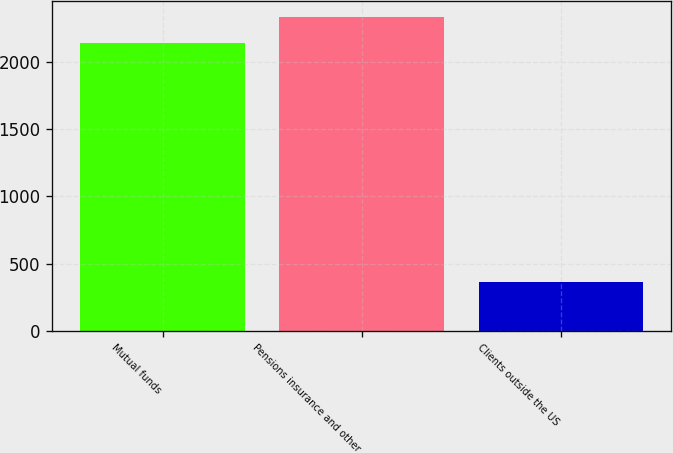Convert chart to OTSL. <chart><loc_0><loc_0><loc_500><loc_500><bar_chart><fcel>Mutual funds<fcel>Pensions insurance and other<fcel>Clients outside the US<nl><fcel>2144<fcel>2338.4<fcel>362<nl></chart> 